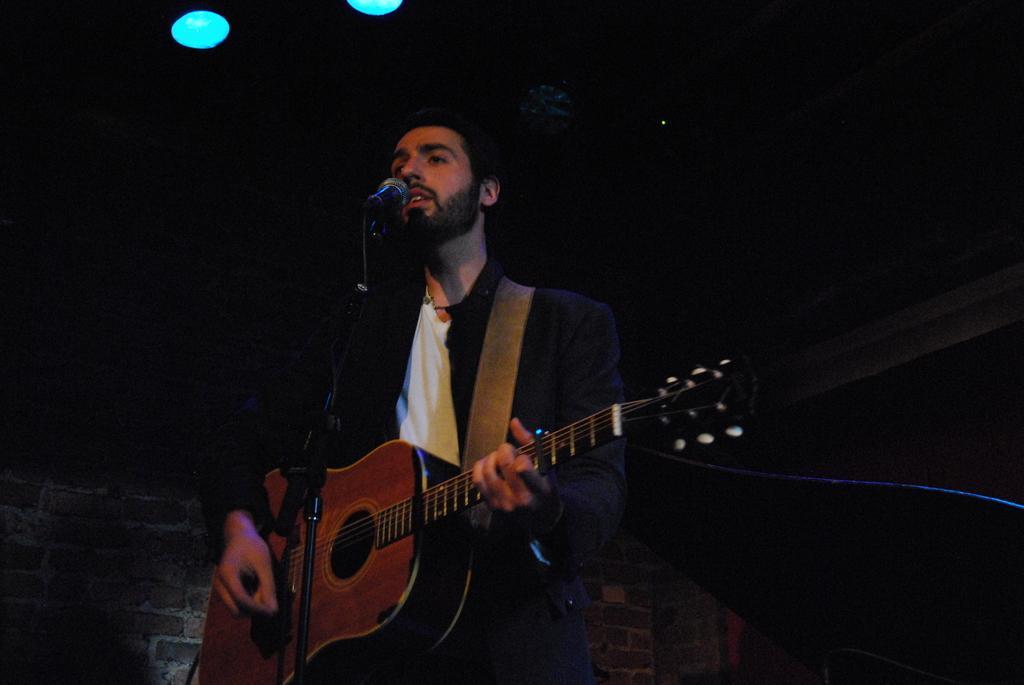Can you describe this image briefly? The person wearing black suit is playing guitar and singing in front of a mic. 